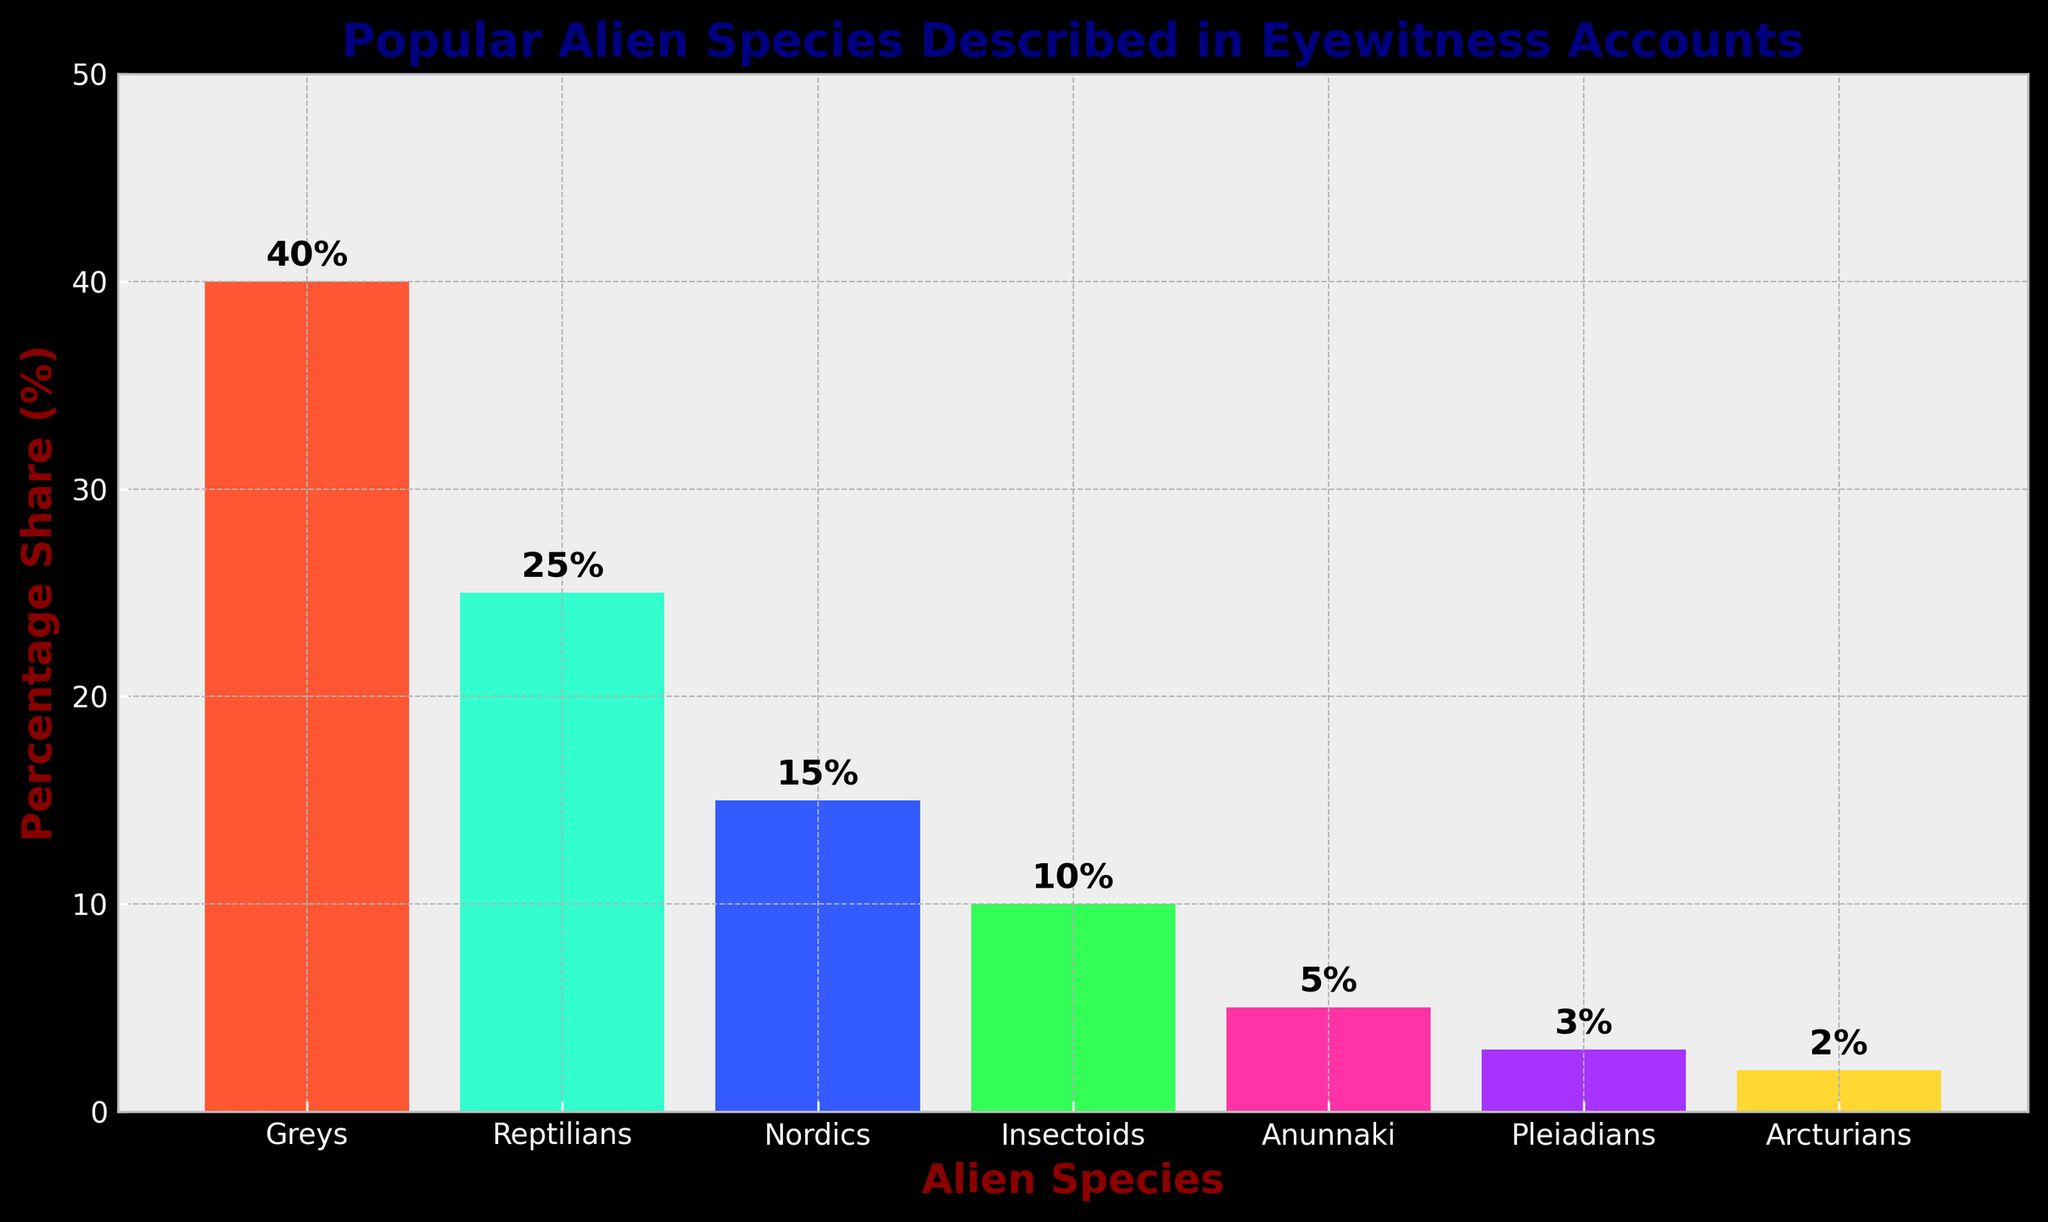Which alien species has the highest percentage in eyewitness accounts? The height of the bars represents the percentage share of each alien species. The "Greys" bar is the tallest, indicating the highest percentage.
Answer: Greys What is the total percentage share of Nordics and Arcturians combined? The percentage share of Nordics is 15%, and Arcturians is 2%. Summing these up, 15% + 2% = 17%.
Answer: 17% Among Reptilians, Nordics, and Pleiadians, which has the lowest percentage share? Compare the height of the bars representing Reptilians (25%), Nordics (15%), and Pleiadians (3%). The Pleiadians bar is the shortest.
Answer: Pleiadians Are there more eyewitness accounts of Insectoids or Nordics? Look at the height of the bars for Insectoids (10%) and Nordics (15%). The Nordics bar is taller.
Answer: Nordics What is the total percentage share of all listed alien species? Sum the percentage values of all species: 40% (Greys) + 25% (Reptilians) + 15% (Nordics) + 10% (Insectoids) + 5% (Anunnaki) + 3% (Pleiadians) + 2% (Arcturians) = 100%.
Answer: 100% How many species have a percentage share greater than 10%? Identify the bars with percentages greater than 10%: Greys (40%), Reptilians (25%), and Nordics (15%). There are three such species.
Answer: 3 What is the percentage difference between Reptilians and Anunnaki? Reptilians have a percentage share of 25%, and Anunnaki have 5%. The difference is 25% - 5% = 20%.
Answer: 20% Which bar is colored in green? Look at the color of the bars: the one representing Reptilians is green.
Answer: Reptilians What is the difference in percentage share between the species with the highest and the species with the lowest percentage share? The highest is Greys with 40%, and the lowest is Arcturians with 2%. The difference is 40% - 2% = 38%.
Answer: 38% What percentage share do the Anunnaki and Pleiadians have combined compared to the Greys? Anunnaki have 5% and Pleiadians have 3%, combined they make 5% + 3% = 8%. Greys have 40%, so the combined share (8%) is lesser.
Answer: Lesser 